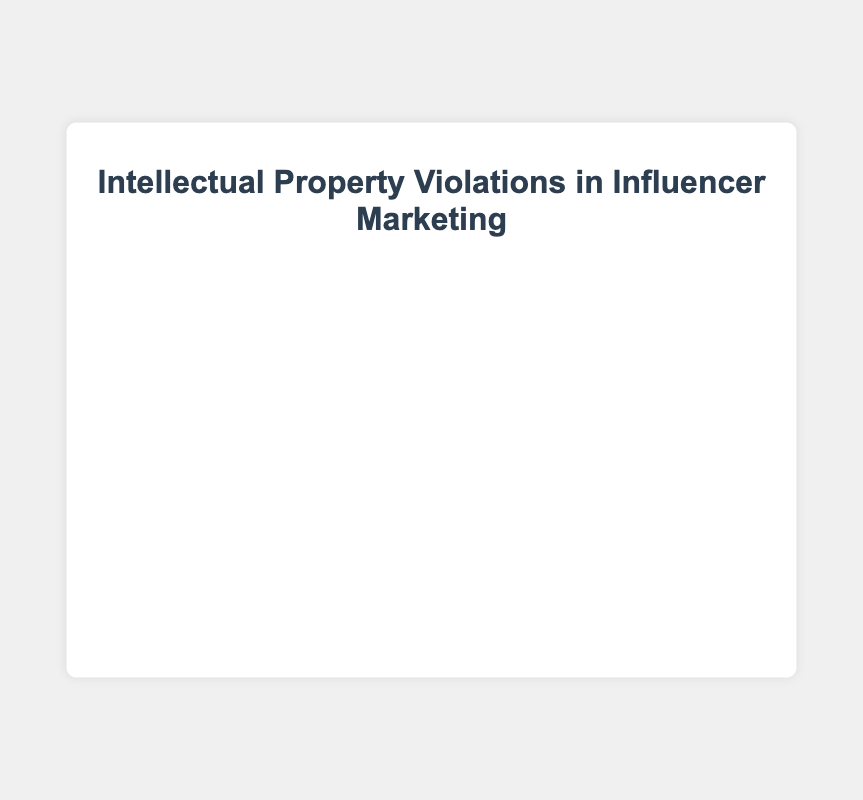What is the most common type of intellectual property violation reported in influencer marketing campaigns? The chart shows that "Unauthorized use of copyrighted music (🎵)" has the highest frequency among the listed violations.
Answer: Unauthorized use of copyrighted music Which type of violation has the lowest frequency? The chart indicates that "Copying other influencers' content (🕵️)" has the lowest frequency among the reported violations.
Answer: Copying other influencers' content How many types of intellectual property violations are displayed in the chart? Counting the different labels in the chart, there are 7 types of intellectual property violations displayed.
Answer: 7 What is the total frequency of the top three most common intellectual property violations? Adding the frequencies of the top three violations: 35 (Unauthorized use of copyrighted music) + 28 (Using trademarked logos without permission) + 22 (Reposting copyrighted images) = 85.
Answer: 85 Which type of violation has a frequency close to 20%? Referring to the chart, "Reposting copyrighted images (🖼️)" has a frequency of 22%, which is closest to 20%.
Answer: Reposting copyrighted images How does the frequency of "Using trademarked logos without permission" compare to "Unattributed quotes from books or articles"? The frequency of "Using trademarked logos without permission (™️)" is 28, which is higher than 15 for "Unattributed quotes from books or articles (📚)."
Answer: Using trademarked logos without permission > Unattributed quotes from books or articles What is the combined frequency of violations related to visual media (images, movie/TV clips, and designs)? Summing up the frequencies of "Reposting copyrighted images (🖼️)" 22, "Unauthorized use of movie/TV clips (🎬)" 10, and "Using patented designs in product reviews (📐)" 7 gives a total: 22 + 10 + 7 = 39.
Answer: 39 Which violation type has a frequency greater than "Using patented designs in product reviews" but less than "Using trademarked logos without permission"? From the chart, "Reposting copyrighted images (🖼️)" has a frequency of 22, which falls between 7 and 28.
Answer: Reposting copyrighted images What's the difference in frequency between the most and least common intellectual property violations? The most common violation has a frequency of 35 (Unauthorized use of copyrighted music), and the least common has 5 (Copying other influencers' content). The difference is 35 - 5 = 30.
Answer: 30 